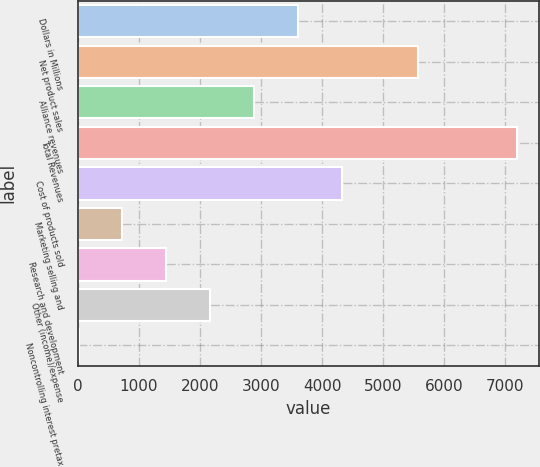Convert chart. <chart><loc_0><loc_0><loc_500><loc_500><bar_chart><fcel>Dollars in Millions<fcel>Net product sales<fcel>Alliance revenues<fcel>Total Revenues<fcel>Cost of products sold<fcel>Marketing selling and<fcel>Research and development<fcel>Other (income)/expense<fcel>Noncontrolling interest pretax<nl><fcel>3606.5<fcel>5568<fcel>2888.4<fcel>7197<fcel>4324.6<fcel>734.1<fcel>1452.2<fcel>2170.3<fcel>16<nl></chart> 